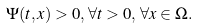Convert formula to latex. <formula><loc_0><loc_0><loc_500><loc_500>\Psi ( t , x ) > 0 , \, \forall t > 0 , \, \forall x \in \Omega .</formula> 